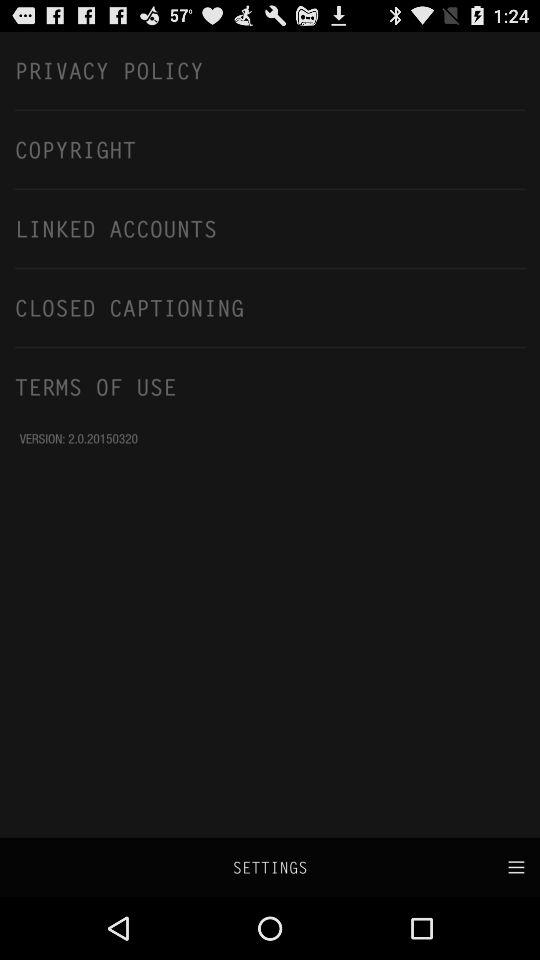What is the version of the application? The version is 2.0.20150320. 